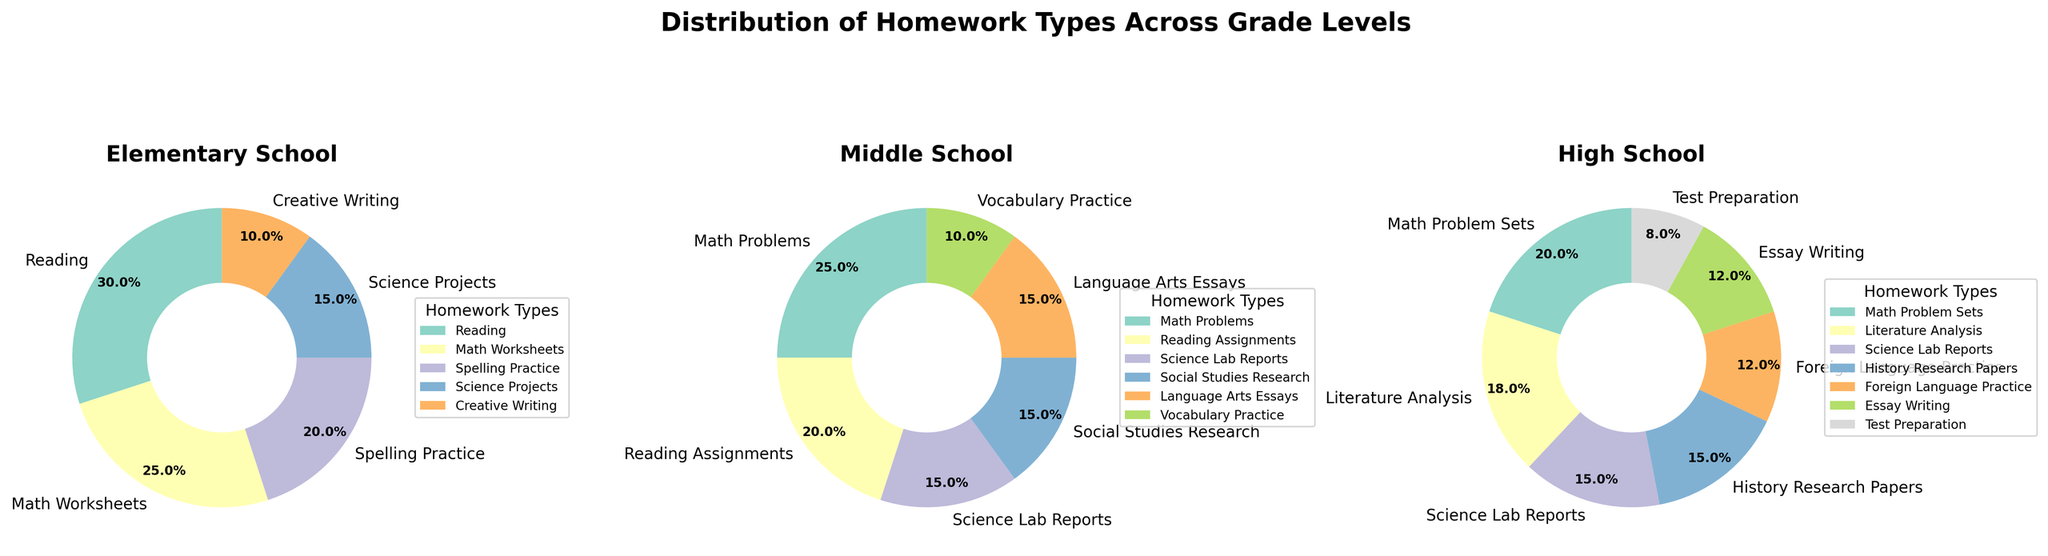Which type of homework is most assigned in Elementary School? To determine the most assigned type of homework in Elementary School, look for the category with the highest percentage on the pie chart.
Answer: Reading What percentage of homework in Middle School involves Math Problems? Find the slice of the pie chart labeled "Math Problems" in the Middle School section and note the percentage.
Answer: 25% How does the percentage of Reading homework in Elementary School compare to Reading Assignments in Middle School? Compare the percentage slice for "Reading" in the Elementary School pie chart with the slice labeled "Reading Assignments" in the Middle School chart.
Answer: Elementary School has more (30% vs. 20%) What is the combined percentage of Science-related homework in High School? Sum the percentages of all categories related to Science in the High School pie chart: "Science Lab Reports" and any other Science-related assignments.
Answer: 15% (Science Lab Reports only) How much more prevalent is Creative Writing homework in Elementary School compared to Essay Writing in High School? Subtract the percentage of Essay Writing in High School from the percentage of Creative Writing in Elementary School.
Answer: 10% - 12% = -2%, meaning Essay Writing in High School is slightly more prevalent Which grade level assigns the highest percentage of Spelling Practice homework? Spelling Practice only appears in the Elementary School pie chart. Assess visually.
Answer: Elementary School What is the difference in the percentage of Math-related homework between Elementary and High School? Add the math-related percentages for High School (Math Problem Sets) and compare with the total Math-related percentage in Elementary School (Math Worksheets).
Answer: 20% (High School) - 25% (Elementary School) = -5% (Elementary School assigns more) In Middle School, how does the percentage of Language Arts Essays compare to Social Studies Research assignments? Compare the two slices labeled "Language Arts Essays" and "Social Studies Research" in the Middle School pie chart.
Answer: They are equal (both 15%) What percentage of homework in High School focuses on Literature Analysis? Locate the slice labeled "Literature Analysis" in the High School pie chart and note its percentage.
Answer: 18% Combining the Elementary and Middle School data, what is the total percentage of vocabulary-related homework? Sum the "Spelling Practice" percentage from Elementary School and "Vocabulary Practice" from Middle School.
Answer: 20% + 10% = 30% 